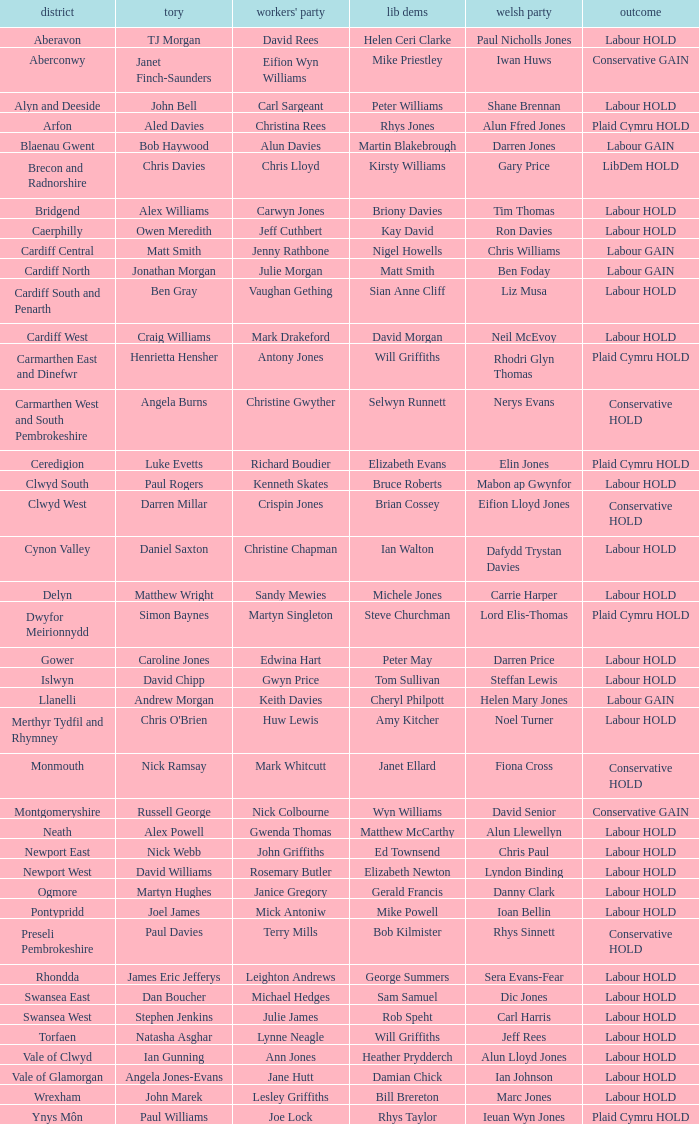In what constituency was the result labour hold and Liberal democrat Elizabeth Newton won? Newport West. 